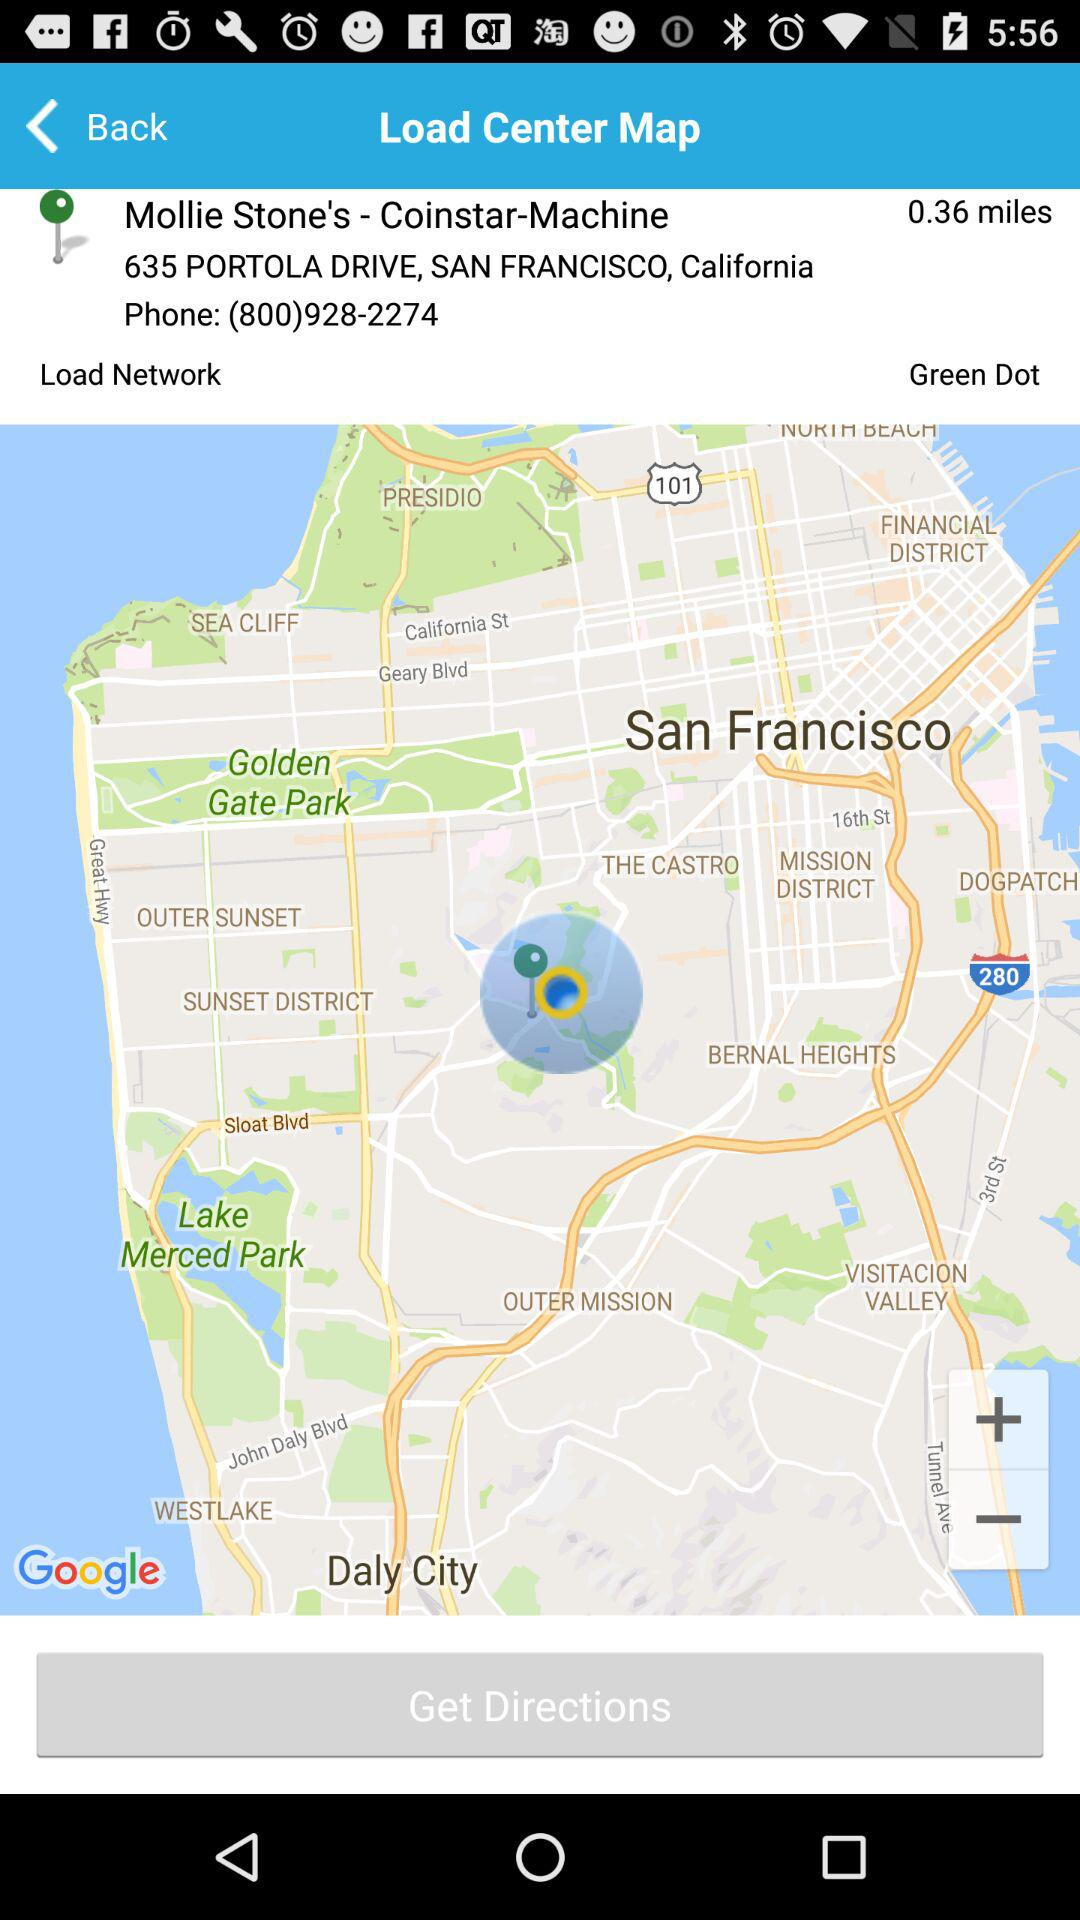What is the shown address? The shown address is 635 Portola Drive, San Francisco, California. 